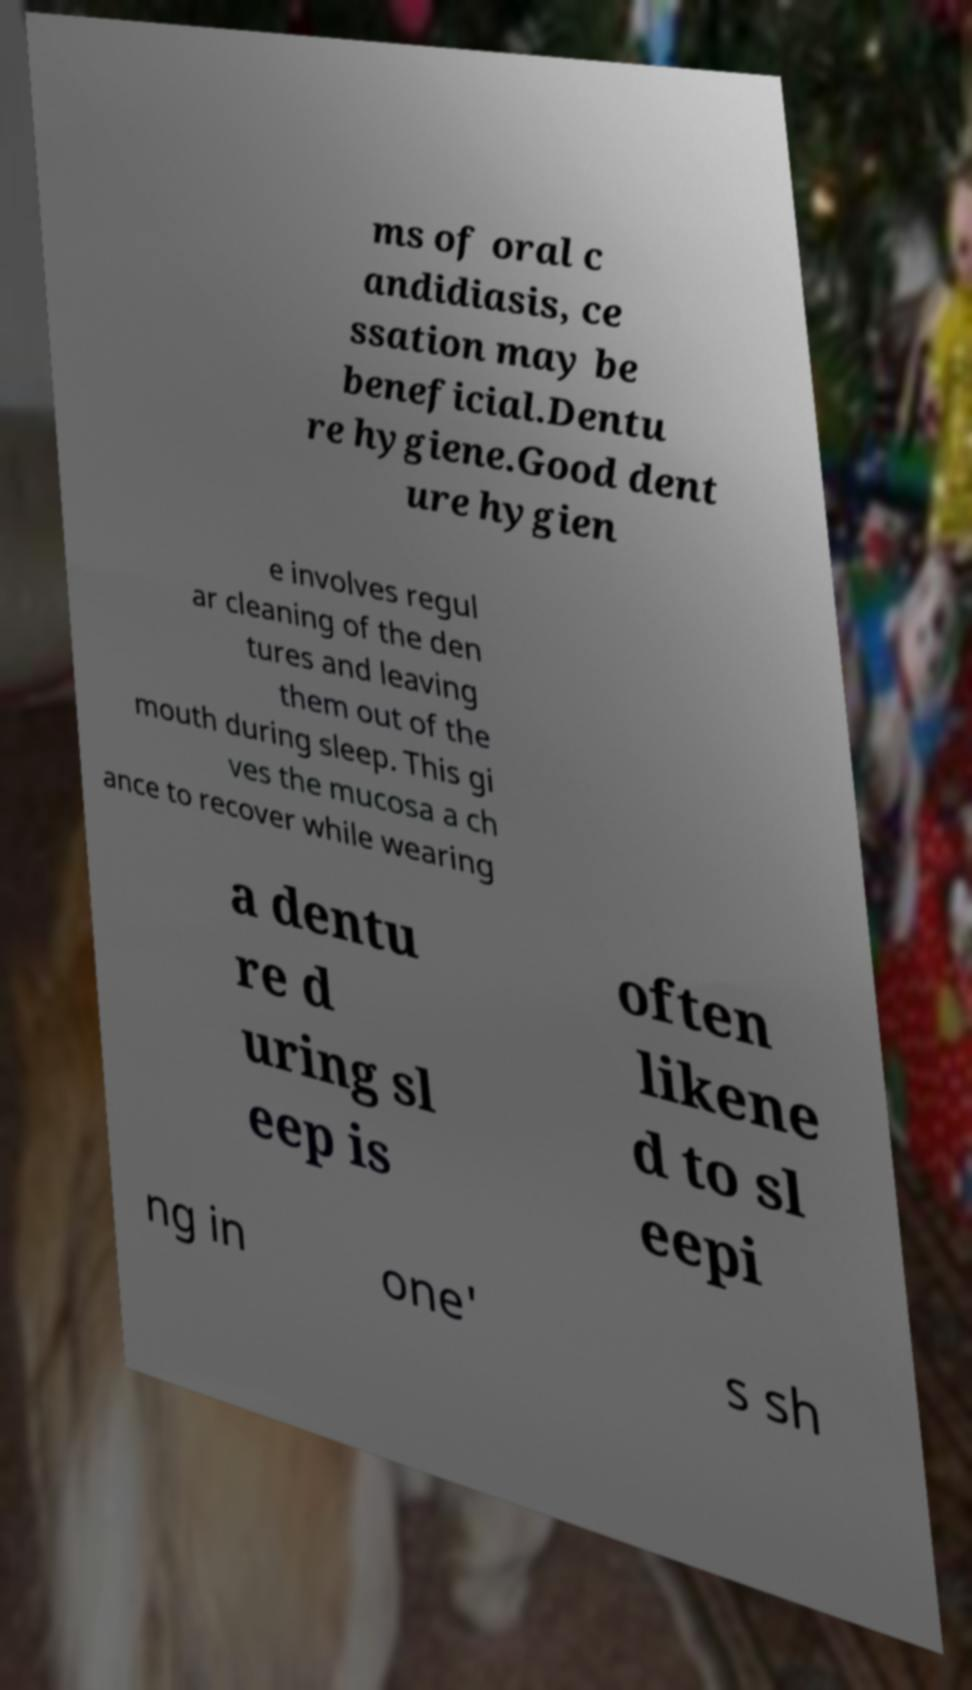For documentation purposes, I need the text within this image transcribed. Could you provide that? ms of oral c andidiasis, ce ssation may be beneficial.Dentu re hygiene.Good dent ure hygien e involves regul ar cleaning of the den tures and leaving them out of the mouth during sleep. This gi ves the mucosa a ch ance to recover while wearing a dentu re d uring sl eep is often likene d to sl eepi ng in one' s sh 